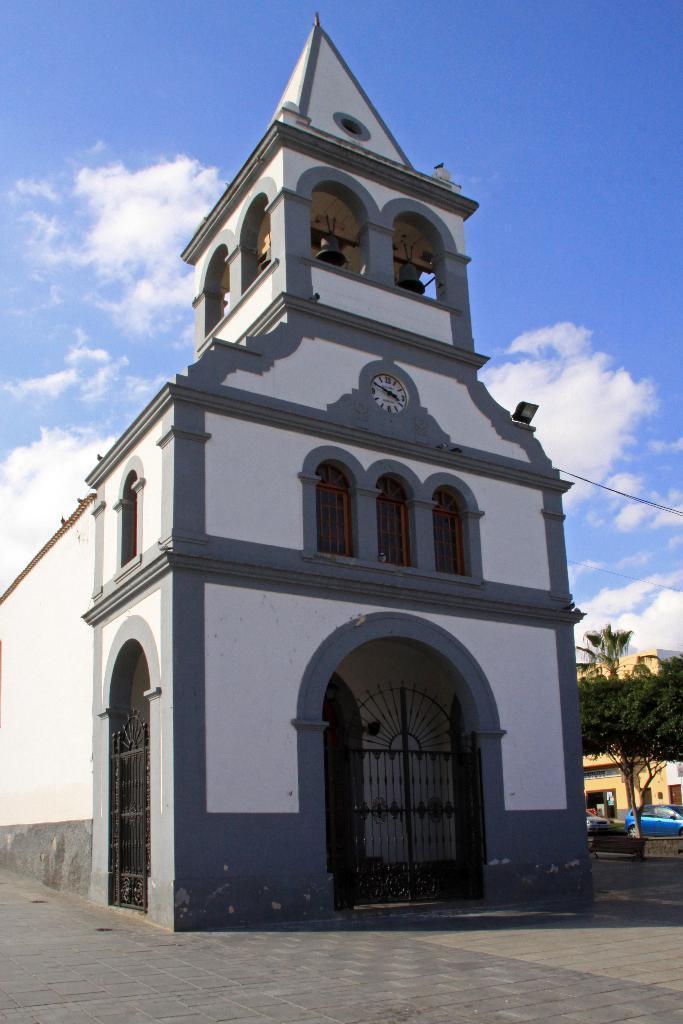What type of structure is present in the image? There is a building in the image. What features can be observed on the building? The building has windows, bells, and a door. Is there any other structure visible in the image? Yes, there is another building in the image. What is the condition of the sky in the image? The sky in the image is cloudy. What else can be seen on the ground in the image? There is a car parked on the ground and a tree. What type of detail can be seen on the car's tires in the image? There is no specific detail mentioned about the car's tires in the provided facts, so it cannot be determined from the image. 